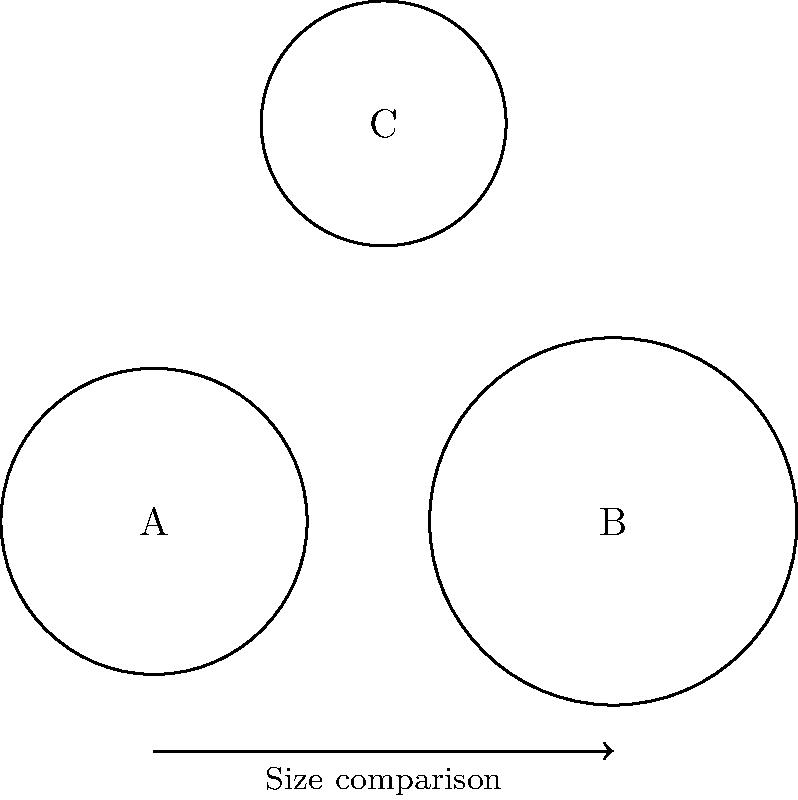In the diagram above, three beauty pageant crowns (A, B, and C) are represented by circles. Which crown has the largest size, and how does the size of crown A compare to crown C? To answer this question, we need to compare the sizes of the crowns represented by circles A, B, and C. Let's analyze step by step:

1. Observe the relative sizes of the circles:
   - Circle A has a medium size
   - Circle B appears to be the largest
   - Circle C is the smallest

2. Compare crown B to the others:
   Crown B is clearly larger than both A and C, making it the largest crown.

3. Compare crown A to crown C:
   Crown A is visibly larger than crown C.

4. Estimate the size difference between A and C:
   The difference in size between A and C is not as pronounced as the difference between B and the others, but it's still noticeable. Crown A appears to be about 20-25% larger than crown C.

Therefore, we can conclude that crown B is the largest, and crown A is larger than crown C by approximately 20-25%.
Answer: B is largest; A is ~25% larger than C 